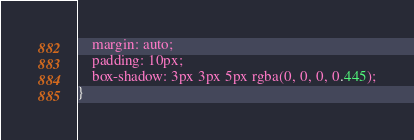<code> <loc_0><loc_0><loc_500><loc_500><_CSS_>    margin: auto;
    padding: 10px;
    box-shadow: 3px 3px 5px rgba(0, 0, 0, 0.445);
}
</code> 